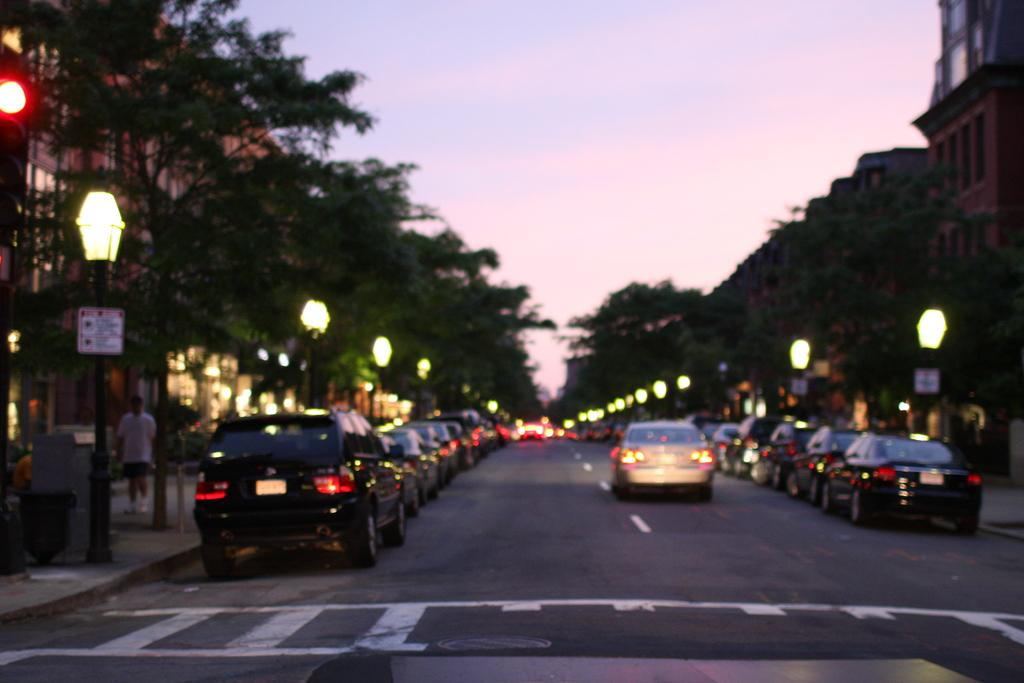What can be seen on the road in the image? There are many vehicles on the road in the image. What is present on the footpaths in the image? There are street lights on the footpaths in the image. What type of vegetation is on the left side of the image? There are many trees on the left side of the image. What is visible behind the footpaths in the image? Behind the footpaths, there are buildings in the image. Can you see any cobwebs hanging from the street lights in the image? There is no mention of cobwebs in the provided facts, and therefore it cannot be determined if any are present in the image. 